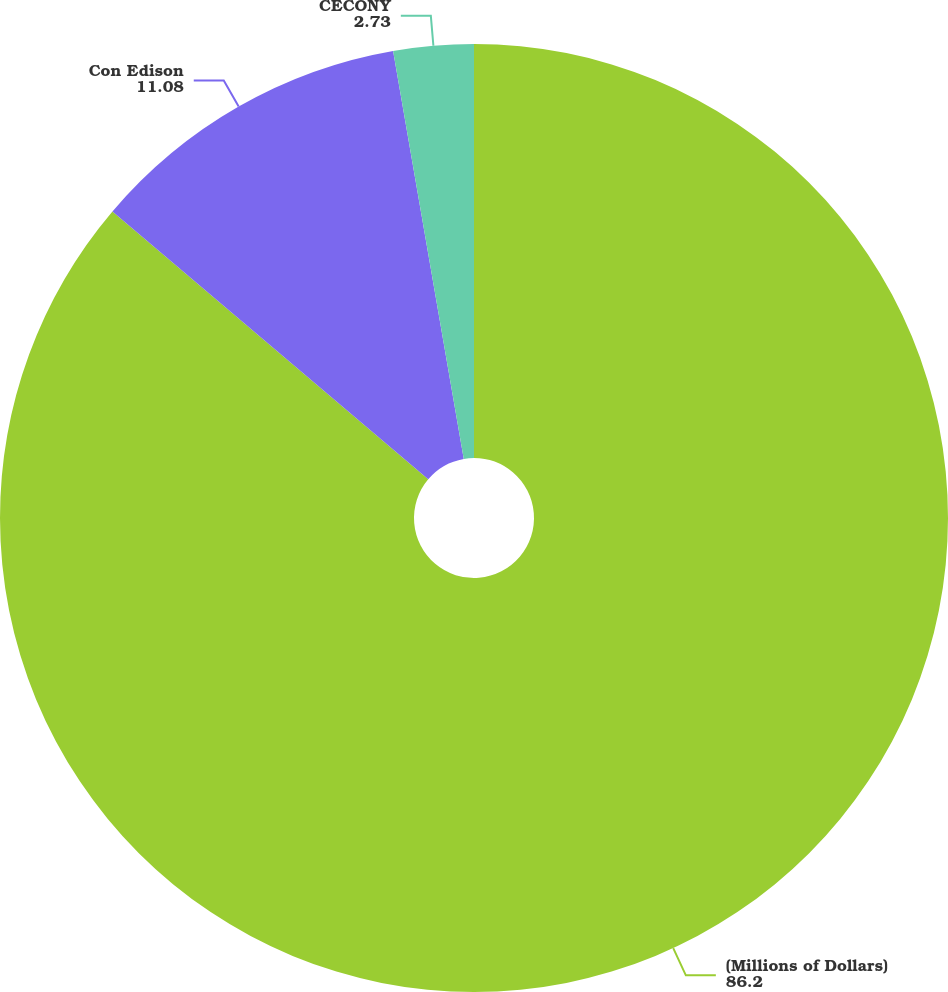Convert chart. <chart><loc_0><loc_0><loc_500><loc_500><pie_chart><fcel>(Millions of Dollars)<fcel>Con Edison<fcel>CECONY<nl><fcel>86.2%<fcel>11.08%<fcel>2.73%<nl></chart> 